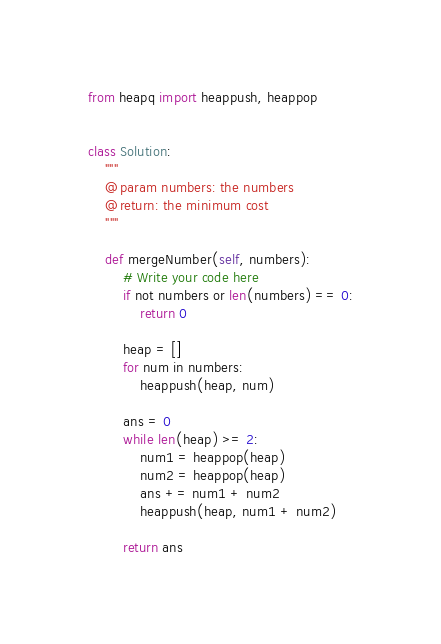Convert code to text. <code><loc_0><loc_0><loc_500><loc_500><_Python_>from heapq import heappush, heappop


class Solution:
    """
    @param numbers: the numbers
    @return: the minimum cost
    """

    def mergeNumber(self, numbers):
        # Write your code here
        if not numbers or len(numbers) == 0:
            return 0

        heap = []
        for num in numbers:
            heappush(heap, num)

        ans = 0
        while len(heap) >= 2:
            num1 = heappop(heap)
            num2 = heappop(heap)
            ans += num1 + num2
            heappush(heap, num1 + num2)

        return ans
</code> 